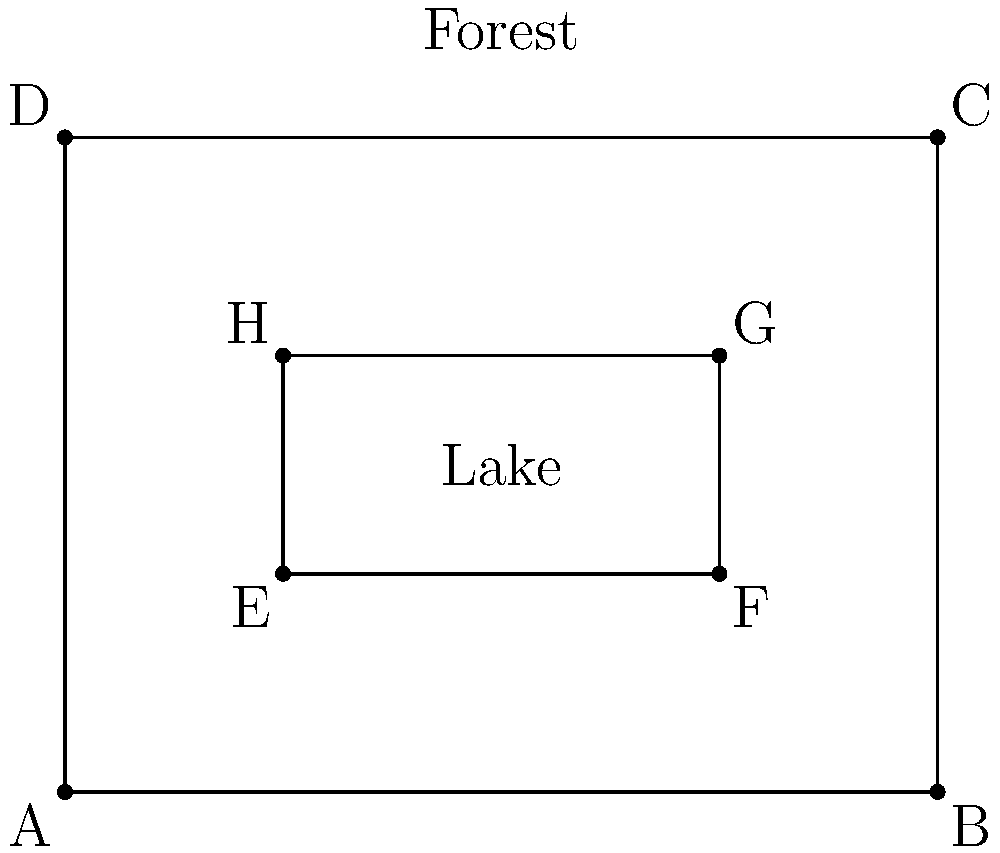In an ecosystem balance infographic, a forest area is represented by rectangle ABCD, and a lake within the forest is represented by rectangle EFGH. If the forest and lake are congruent to each other when scaled, what is the scale factor between the lake and the forest? To find the scale factor between the lake and the forest, we need to compare their corresponding sides. Let's follow these steps:

1. Identify the dimensions of the forest (ABCD):
   Length of AB = 4 units
   Width of AD = 3 units

2. Identify the dimensions of the lake (EFGH):
   Length of EF = 2 units
   Width of EH = 1 unit

3. Calculate the scale factor:
   For length: $\frac{\text{Lake length}}{\text{Forest length}} = \frac{2}{4} = \frac{1}{2}$
   For width: $\frac{\text{Lake width}}{\text{Forest width}} = \frac{1}{3}$

4. Verify that both ratios are equal:
   $\frac{1}{2} = 0.5$ and $\frac{1}{3} \approx 0.33$

   The ratios are not equal, so we need to adjust our assumption.

5. Recalculate using the length ratio:
   Scale factor = $\frac{2}{4} = \frac{1}{2}$

6. Verify this scale factor for the width:
   $3 \times \frac{1}{2} = 1.5$, which is indeed the width of the lake

Therefore, the scale factor between the lake and the forest is $\frac{1}{2}$ or 0.5.
Answer: $\frac{1}{2}$ 